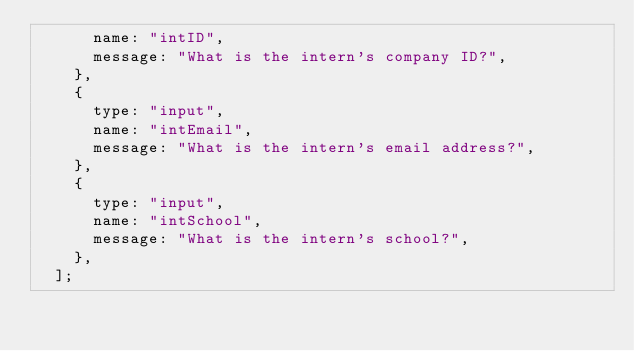Convert code to text. <code><loc_0><loc_0><loc_500><loc_500><_JavaScript_>      name: "intID",
      message: "What is the intern's company ID?",
    },
    {
      type: "input",
      name: "intEmail",
      message: "What is the intern's email address?",
    },
    {
      type: "input",
      name: "intSchool",
      message: "What is the intern's school?",
    },
  ];</code> 